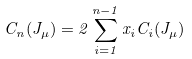Convert formula to latex. <formula><loc_0><loc_0><loc_500><loc_500>C _ { n } ( J _ { \mu } ) = 2 \sum ^ { n - 1 } _ { i = 1 } x _ { i } C _ { i } ( J _ { \mu } )</formula> 